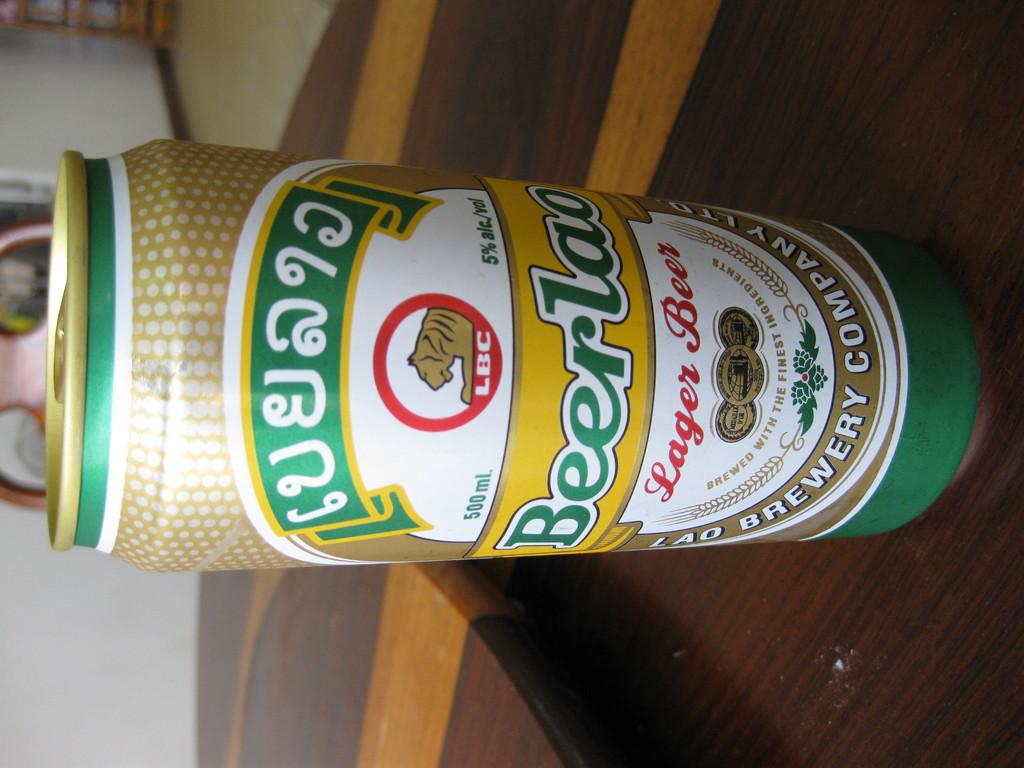What is the alcohol content of the beer?
Offer a very short reply. 5%. 